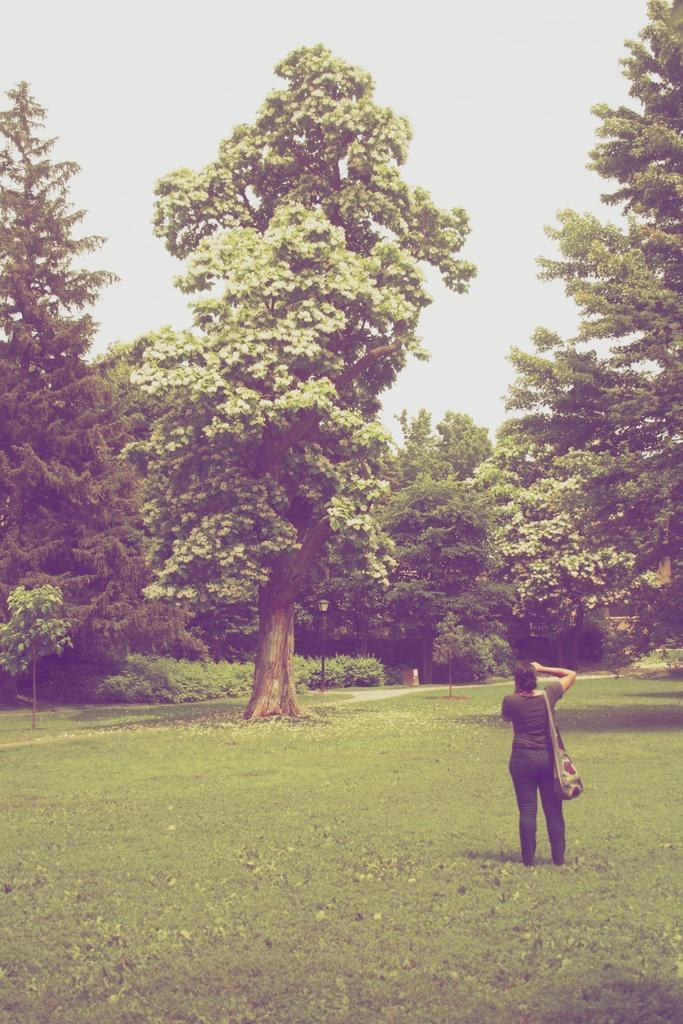Could you give a brief overview of what you see in this image? This is an outside view. At the bottom, I can see the grass on the ground. On the right side there is a woman wearing a bag and standing facing towards the back side. In the background there are many trees. At the top of the image I can see the sky. 